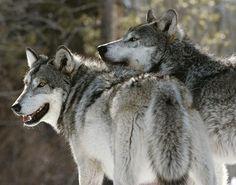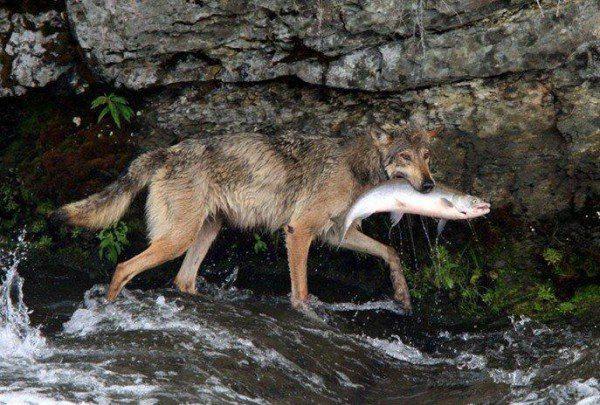The first image is the image on the left, the second image is the image on the right. Given the left and right images, does the statement "At least one wolf has its mouth open." hold true? Answer yes or no. Yes. 